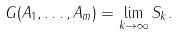Convert formula to latex. <formula><loc_0><loc_0><loc_500><loc_500>G ( A _ { 1 } , \dots , A _ { m } ) = \underset { k \rightarrow \infty } { \lim } \, S _ { k } .</formula> 